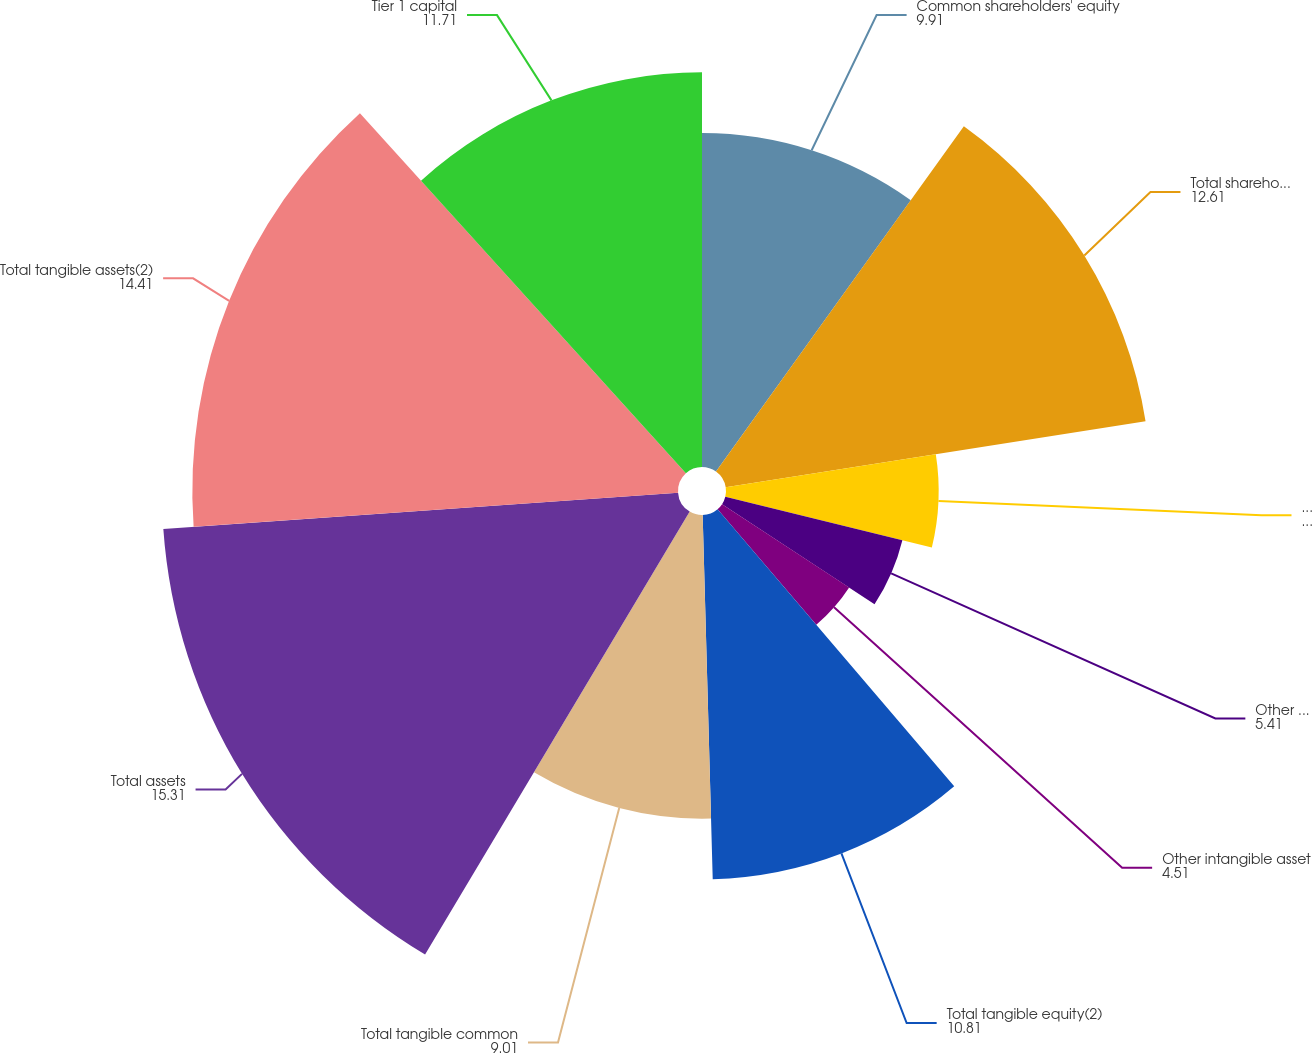<chart> <loc_0><loc_0><loc_500><loc_500><pie_chart><fcel>Common shareholders' equity<fcel>Total shareholders' equity<fcel>Goodwill<fcel>Other intangible assets<fcel>Other intangible asset<fcel>Total tangible equity(2)<fcel>Total tangible common<fcel>Total assets<fcel>Total tangible assets(2)<fcel>Tier 1 capital<nl><fcel>9.91%<fcel>12.61%<fcel>6.31%<fcel>5.41%<fcel>4.51%<fcel>10.81%<fcel>9.01%<fcel>15.31%<fcel>14.41%<fcel>11.71%<nl></chart> 